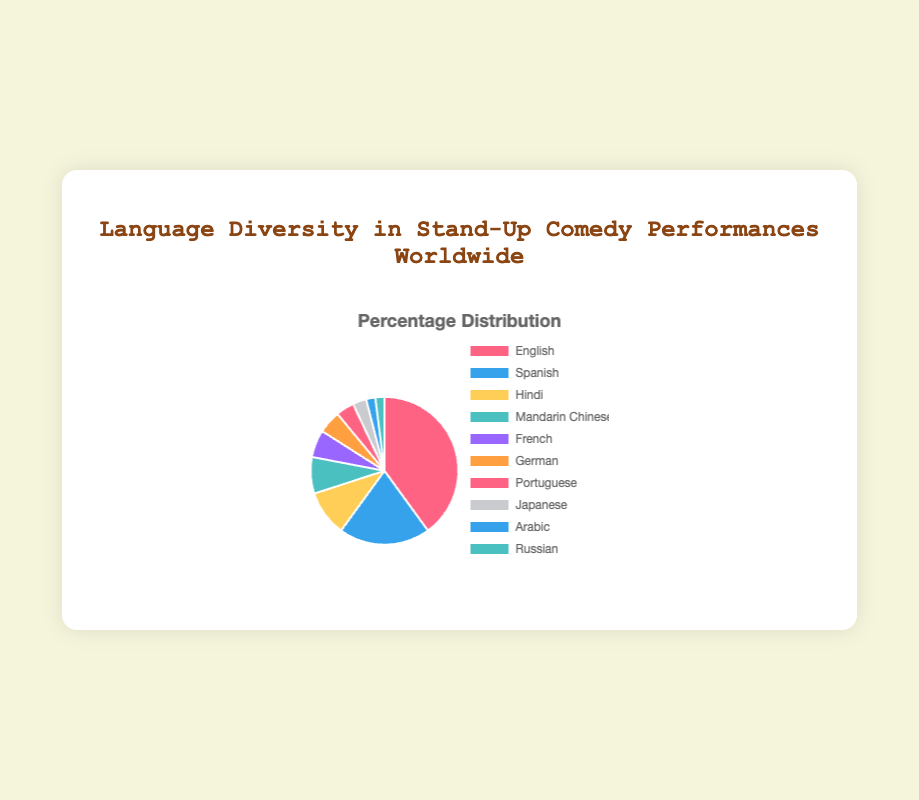Which language has the highest percentage of stand-up comedy performances? The chart shows that the language with the largest segment corresponds to English, with a percentage of 40%.
Answer: English Which languages have the same percentage of stand-up comedy performances? The chart includes Arabic and Russian, both with a percentage of 2%, so these two languages have the same representation.
Answer: Arabic and Russian What is the combined percentage of stand-up comedy performances in French, German, and Portuguese? The chart shows the individual percentages: French (6%), German (5%), and Portuguese (4%). Summing these up gives 6 + 5 + 4 = 15%.
Answer: 15% Which language category is represented by the green-colored segment in the pie chart? The green-colored segment in the pie chart represents Hindi, with a percentage of 10%.
Answer: Hindi How much more popular is English compared to Mandarin Chinese for stand-up comedy performances? The chart shows that English has 40% while Mandarin Chinese has 8%. The difference is calculated as 40% - 8% = 32%.
Answer: 32% What is the average percentage of stand-up comedy performances in Spanish, Hindi, and Japanese? The individual percentages for these languages are Spanish (20%), Hindi (10%), and Japanese (3%). Summing them up gives 20 + 10 + 3 = 33%, and the average is 33% / 3 = 11%.
Answer: 11% Which languages collectively contribute to less than 10% of stand-up comedy performances? The chart lists Japanese, Arabic, and Russian as having 3%, 2%, and 2% respectively. Summing them up gives 3 + 2 + 2 = 7%, which is less than 10%.
Answer: Japanese, Arabic, and Russian If the percentage of performances in Spanish was doubled, what would be the new combined percentage of English and Spanish? The current percentage of Spanish is 20%, so doubling it would give 20% * 2 = 40%. Adding this to the percentage for English, which is 40%, gives 40% + 40% = 80%.
Answer: 80% Which language has a higher percentage of stand-up comedy performances, French or German, and by how much? The chart shows that French has 6% and German has 5%. The difference is calculated as 6% - 5% = 1%.
Answer: French by 1% 